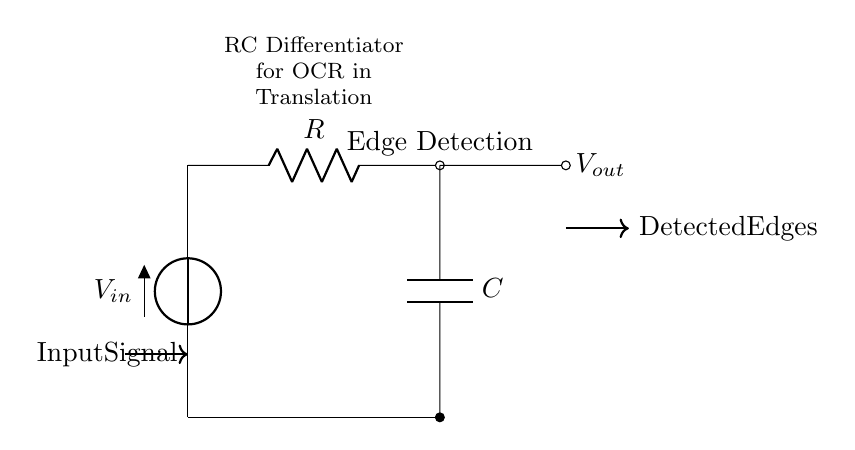What type of circuit is shown? The circuit is an RC differentiator, which consists of a resistor and a capacitor used together to differentiate input signals.
Answer: RC differentiator What is the role of the resistor in this circuit? The resistor limits the current flow and together with the capacitor, forms the differentiating function that reacts to changes in voltage, helping in edge detection.
Answer: Current limiting What is the output signal represented by? The output signal represents the detected edges of the input signal, highlighting transitions or changes in the signal level over time.
Answer: Detected edges What is the function of the capacitor in this circuit? The capacitor stores and releases energy, allowing it to react to fast changes in the input signal to produce an output voltage that is proportional to the rate of change of the input signal.
Answer: Energy storage What happens to the output voltage when the input signal rapidly changes? When the input signal rapidly changes, the output voltage experiences a spike, indicating that an edge has been detected in the input signal due to the differentiating action of the RC circuit.
Answer: Output spike How can this circuit be applied in optical character recognition systems? This circuit can be applied in OCR systems to process the electrical signals from optical sensors, detecting edges that correspond to the characters being recognized for translation processes.
Answer: Edge detection in OCR 